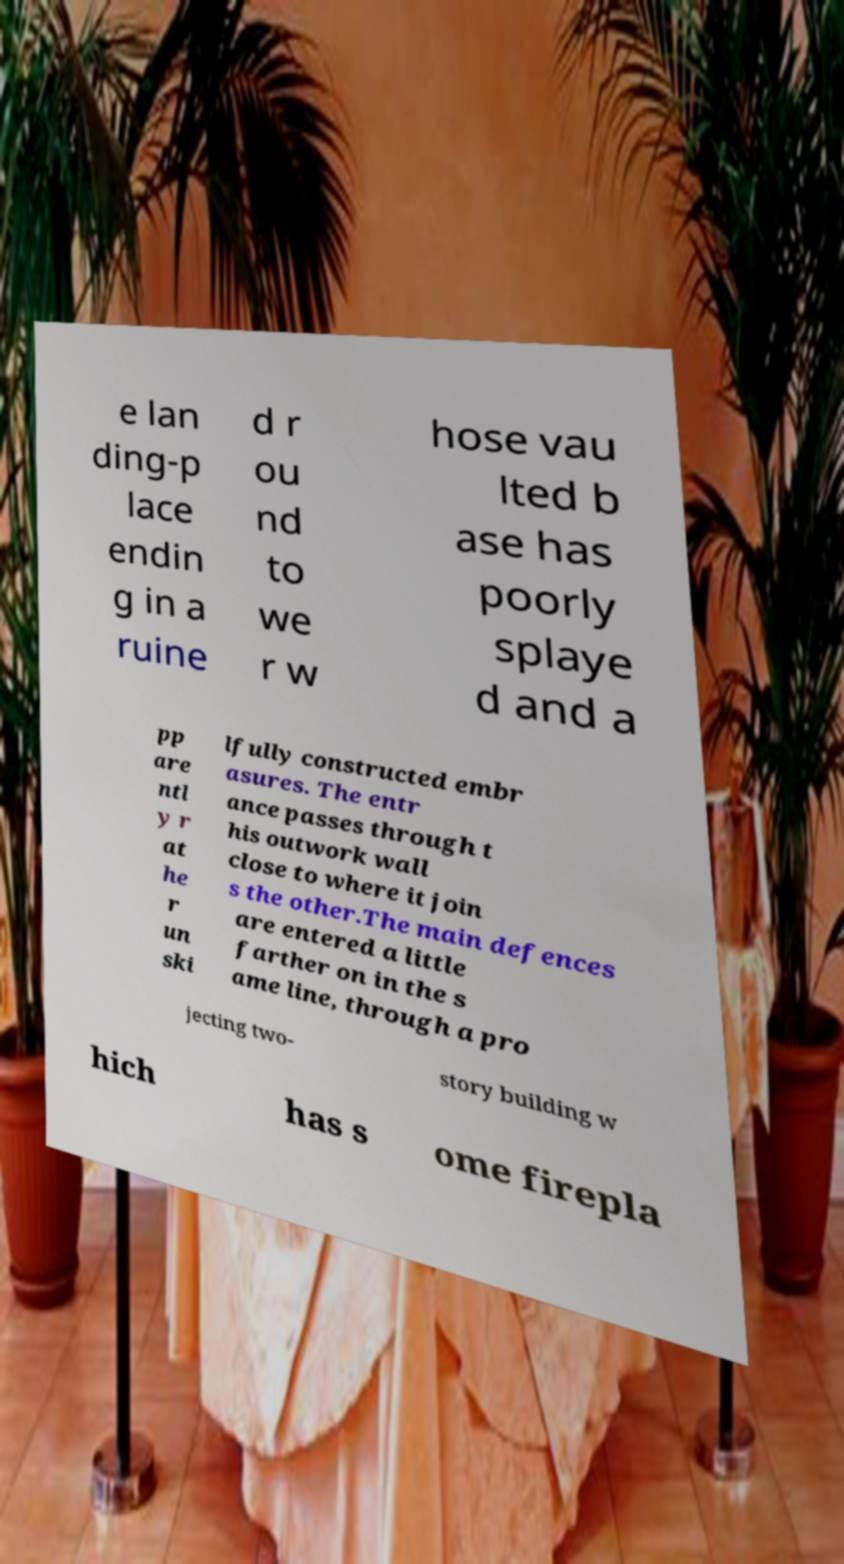Could you extract and type out the text from this image? e lan ding-p lace endin g in a ruine d r ou nd to we r w hose vau lted b ase has poorly splaye d and a pp are ntl y r at he r un ski lfully constructed embr asures. The entr ance passes through t his outwork wall close to where it join s the other.The main defences are entered a little farther on in the s ame line, through a pro jecting two- story building w hich has s ome firepla 